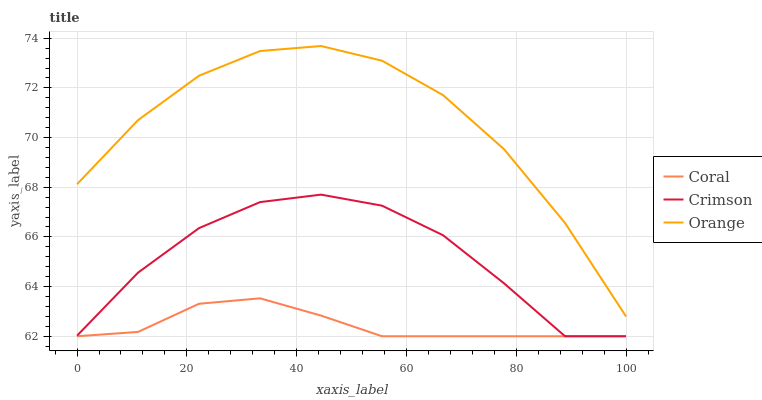Does Coral have the minimum area under the curve?
Answer yes or no. Yes. Does Orange have the maximum area under the curve?
Answer yes or no. Yes. Does Orange have the minimum area under the curve?
Answer yes or no. No. Does Coral have the maximum area under the curve?
Answer yes or no. No. Is Coral the smoothest?
Answer yes or no. Yes. Is Crimson the roughest?
Answer yes or no. Yes. Is Orange the smoothest?
Answer yes or no. No. Is Orange the roughest?
Answer yes or no. No. Does Orange have the lowest value?
Answer yes or no. No. Does Orange have the highest value?
Answer yes or no. Yes. Does Coral have the highest value?
Answer yes or no. No. Is Crimson less than Orange?
Answer yes or no. Yes. Is Orange greater than Crimson?
Answer yes or no. Yes. Does Coral intersect Crimson?
Answer yes or no. Yes. Is Coral less than Crimson?
Answer yes or no. No. Is Coral greater than Crimson?
Answer yes or no. No. Does Crimson intersect Orange?
Answer yes or no. No. 